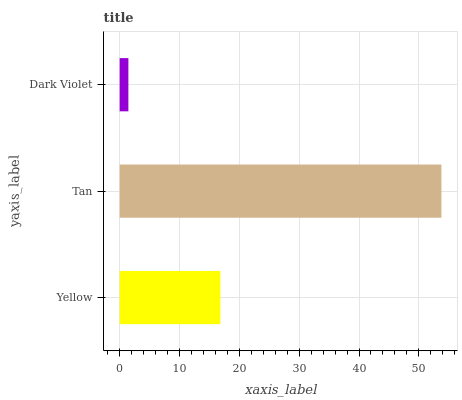Is Dark Violet the minimum?
Answer yes or no. Yes. Is Tan the maximum?
Answer yes or no. Yes. Is Tan the minimum?
Answer yes or no. No. Is Dark Violet the maximum?
Answer yes or no. No. Is Tan greater than Dark Violet?
Answer yes or no. Yes. Is Dark Violet less than Tan?
Answer yes or no. Yes. Is Dark Violet greater than Tan?
Answer yes or no. No. Is Tan less than Dark Violet?
Answer yes or no. No. Is Yellow the high median?
Answer yes or no. Yes. Is Yellow the low median?
Answer yes or no. Yes. Is Tan the high median?
Answer yes or no. No. Is Dark Violet the low median?
Answer yes or no. No. 